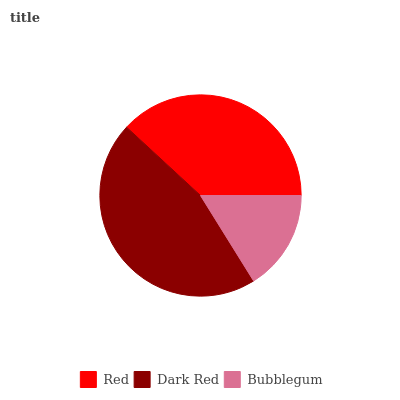Is Bubblegum the minimum?
Answer yes or no. Yes. Is Dark Red the maximum?
Answer yes or no. Yes. Is Dark Red the minimum?
Answer yes or no. No. Is Bubblegum the maximum?
Answer yes or no. No. Is Dark Red greater than Bubblegum?
Answer yes or no. Yes. Is Bubblegum less than Dark Red?
Answer yes or no. Yes. Is Bubblegum greater than Dark Red?
Answer yes or no. No. Is Dark Red less than Bubblegum?
Answer yes or no. No. Is Red the high median?
Answer yes or no. Yes. Is Red the low median?
Answer yes or no. Yes. Is Dark Red the high median?
Answer yes or no. No. Is Bubblegum the low median?
Answer yes or no. No. 